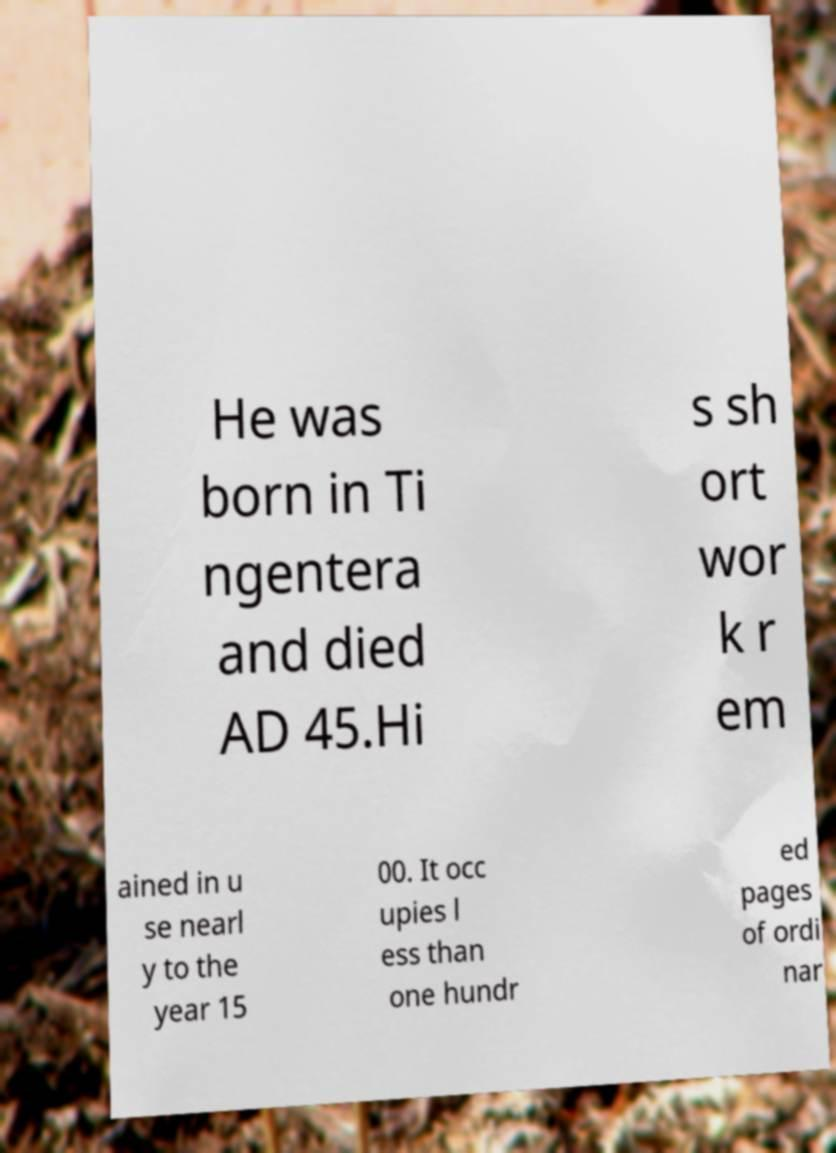For documentation purposes, I need the text within this image transcribed. Could you provide that? He was born in Ti ngentera and died AD 45.Hi s sh ort wor k r em ained in u se nearl y to the year 15 00. It occ upies l ess than one hundr ed pages of ordi nar 